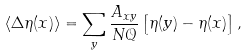Convert formula to latex. <formula><loc_0><loc_0><loc_500><loc_500>\langle \Delta \eta ( x ) \rangle = \sum _ { y } \frac { A _ { x y } } { N \mathcal { Q } } \left [ \eta ( y ) - \eta ( x ) \right ] ,</formula> 